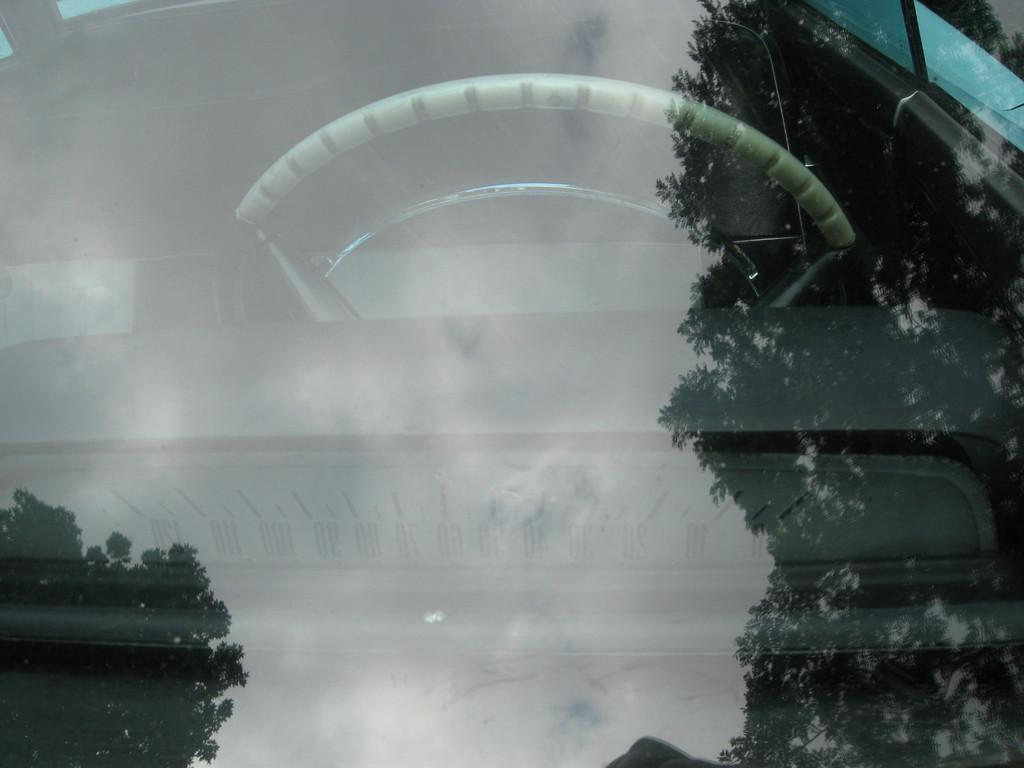What is the main subject in the foreground of the image? There is a windshield of a car in the foreground of the image. What can be seen inside the car through the windshield? A steering wheel is visible inside the car. What is reflected on the glass of the windshield? There is a reflection of a tree and the sky on the glass. What type of notebook is placed on the dashboard in the image? There is no notebook present in the image; it only features a windshield, a steering wheel, and reflections on the glass. 